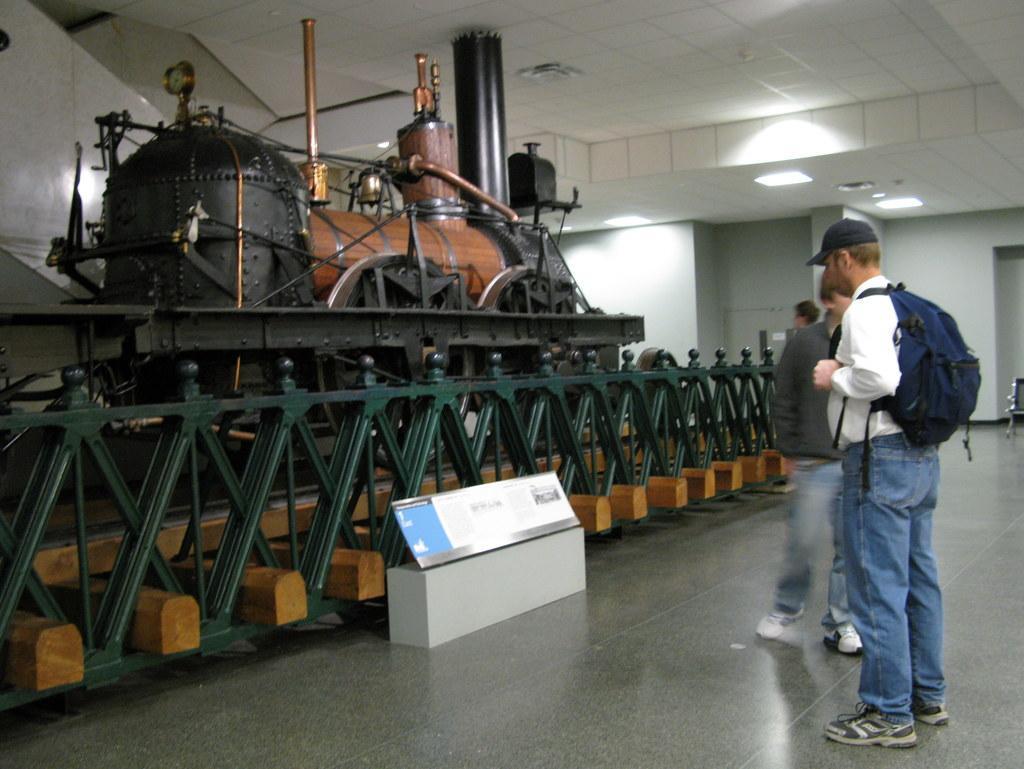Describe this image in one or two sentences. In the picture we can see a train engine beside it, we can see a railing and near it, we can see two people are standing, one man is wearing a bag and cap and to the ceiling we can see the lights. 